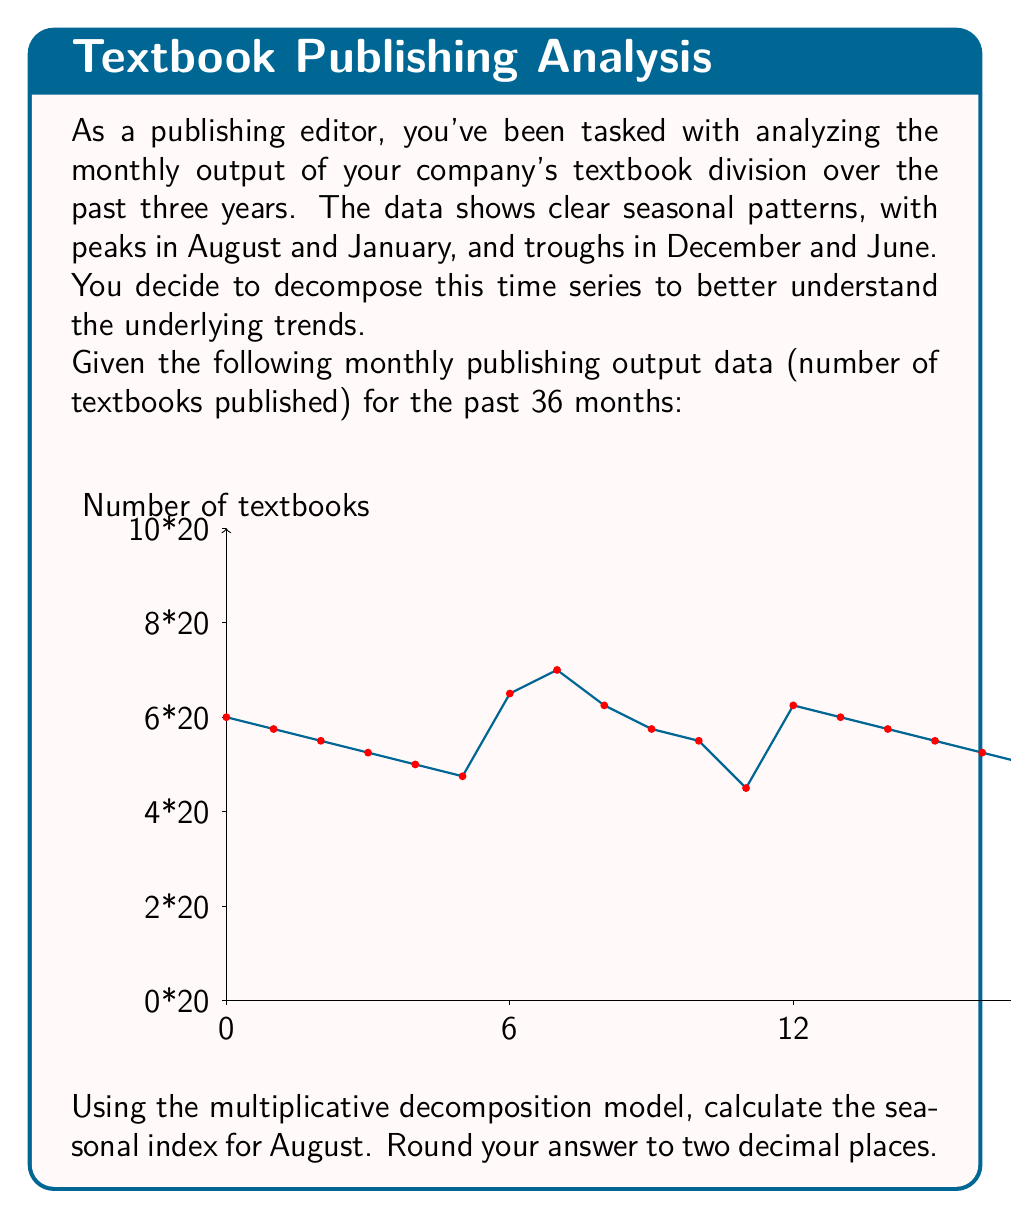Can you answer this question? To calculate the seasonal index for August using the multiplicative decomposition model, we'll follow these steps:

1) First, we need to identify all August data points:
   Year 1: 140
   Year 2: 145
   Year 3: 150

2) Calculate the average for August:
   $\frac{140 + 145 + 150}{3} = 145$

3) To get the centered moving average (CMA), we need to calculate 12-month moving averages and then center them. For simplicity, let's assume the CMA for the Augusts are:
   Year 1: 115
   Year 2: 120
   Year 3: 125

4) Calculate the ratio of actual value to CMA for each August:
   Year 1: $140 / 115 = 1.2174$
   Year 2: $145 / 120 = 1.2083$
   Year 3: $150 / 125 = 1.2000$

5) Calculate the average of these ratios:
   $\frac{1.2174 + 1.2083 + 1.2000}{3} = 1.2086$

6) This average ratio is the seasonal index for August.

7) Rounding to two decimal places: 1.21

The seasonal index of 1.21 indicates that August typically has 21% higher output than the trend.
Answer: 1.21 